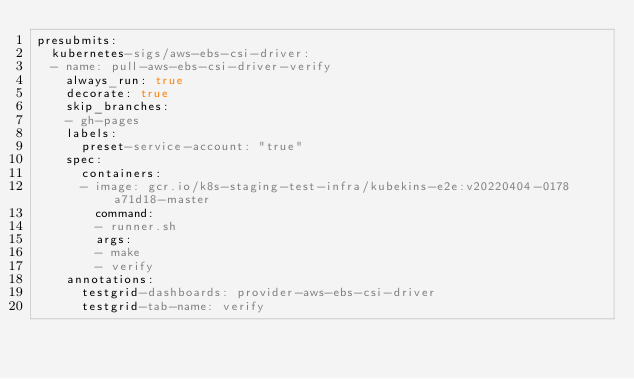Convert code to text. <code><loc_0><loc_0><loc_500><loc_500><_YAML_>presubmits:
  kubernetes-sigs/aws-ebs-csi-driver:
  - name: pull-aws-ebs-csi-driver-verify
    always_run: true
    decorate: true
    skip_branches:
    - gh-pages
    labels:
      preset-service-account: "true"
    spec:
      containers:
      - image: gcr.io/k8s-staging-test-infra/kubekins-e2e:v20220404-0178a71d18-master
        command:
        - runner.sh
        args:
        - make
        - verify
    annotations:
      testgrid-dashboards: provider-aws-ebs-csi-driver
      testgrid-tab-name: verify</code> 